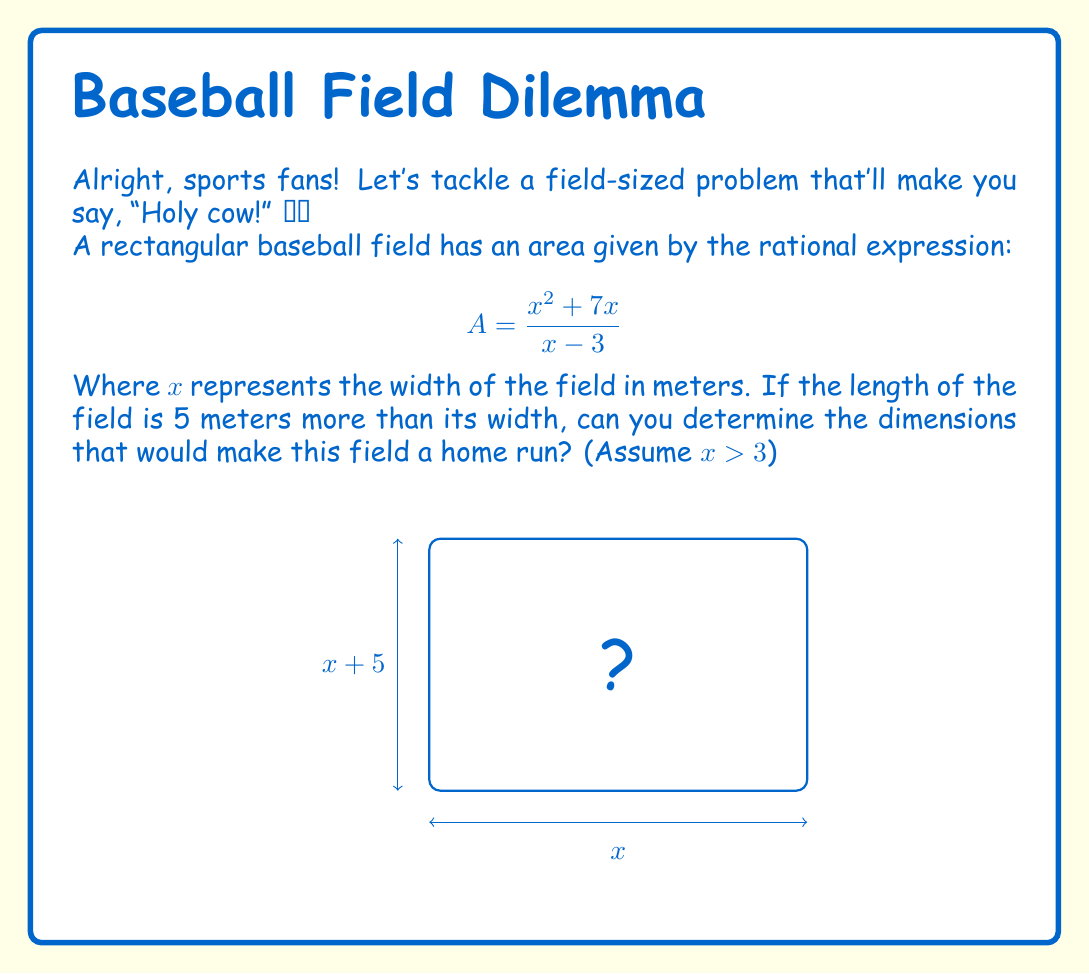Teach me how to tackle this problem. Let's knock this problem out of the park step by step:

1) We know the length is 5 meters more than the width, so we can express it as $(x + 5)$.

2) The area of a rectangle is length times width, so:
   $$A = x(x + 5)$$

3) This should equal our given rational expression:
   $$\frac{x^2 + 7x}{x - 3} = x(x + 5)$$

4) Let's expand the right side:
   $$\frac{x^2 + 7x}{x - 3} = x^2 + 5x$$

5) Now, let's cross-multiply:
   $$(x^2 + 7x) = (x^2 + 5x)(x - 3)$$

6) Expand the right side:
   $$x^2 + 7x = x^3 + 5x^2 - 3x^2 - 15x$$
   $$x^2 + 7x = x^3 + 2x^2 - 15x$$

7) Subtract $x^2$ and $7x$ from both sides:
   $$0 = x^3 + x^2 - 22x$$

8) Factor out $x$:
   $$0 = x(x^2 + x - 22)$$

9) Use the quadratic formula or factoring to solve $x^2 + x - 22 = 0$:
   $$(x + 5)(x - 4) = 0$$
   So, $x = 4$ or $x = -5$ (but we're told $x > 3$, so we discard -5)

10) Therefore, the width is 4 meters and the length is $4 + 5 = 9$ meters.
Answer: Width: 4m, Length: 9m 